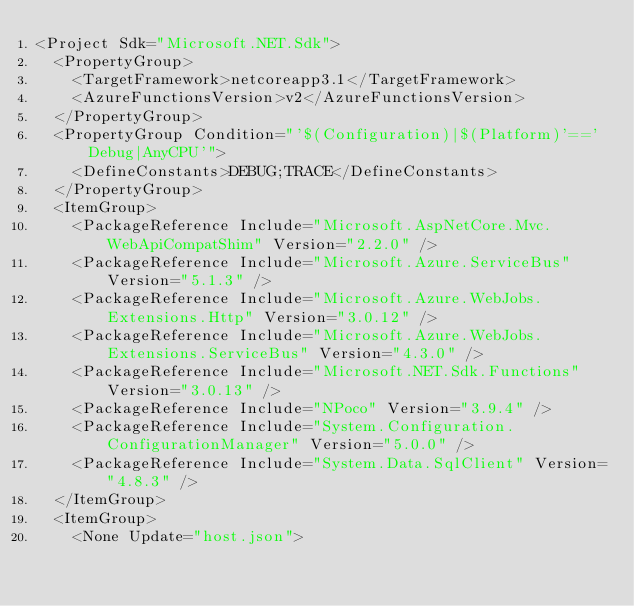Convert code to text. <code><loc_0><loc_0><loc_500><loc_500><_XML_><Project Sdk="Microsoft.NET.Sdk">
  <PropertyGroup>
    <TargetFramework>netcoreapp3.1</TargetFramework>
    <AzureFunctionsVersion>v2</AzureFunctionsVersion>
  </PropertyGroup>
  <PropertyGroup Condition="'$(Configuration)|$(Platform)'=='Debug|AnyCPU'">
    <DefineConstants>DEBUG;TRACE</DefineConstants>
  </PropertyGroup>
  <ItemGroup>
    <PackageReference Include="Microsoft.AspNetCore.Mvc.WebApiCompatShim" Version="2.2.0" />
    <PackageReference Include="Microsoft.Azure.ServiceBus" Version="5.1.3" />
    <PackageReference Include="Microsoft.Azure.WebJobs.Extensions.Http" Version="3.0.12" />
    <PackageReference Include="Microsoft.Azure.WebJobs.Extensions.ServiceBus" Version="4.3.0" />
    <PackageReference Include="Microsoft.NET.Sdk.Functions" Version="3.0.13" />
    <PackageReference Include="NPoco" Version="3.9.4" />
    <PackageReference Include="System.Configuration.ConfigurationManager" Version="5.0.0" />
    <PackageReference Include="System.Data.SqlClient" Version="4.8.3" />
  </ItemGroup>
  <ItemGroup>
    <None Update="host.json"></code> 